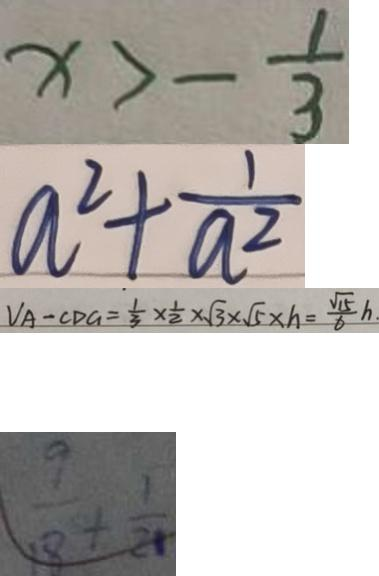Convert formula to latex. <formula><loc_0><loc_0><loc_500><loc_500>x > - \frac { 1 } { 3 } 
 a ^ { 2 } + \frac { 1 } { a ^ { 2 } } 
 V _ { A } - C D G = \frac { 1 } { 3 } \times \frac { 1 } { 2 } \times \sqrt { 3 } \times \sqrt { 5 } \times h = \frac { \sqrt { 1 5 } } { 6 } h 
 \frac { 9 } { 1 8 } + \frac { 1 } { 2 1 }</formula> 